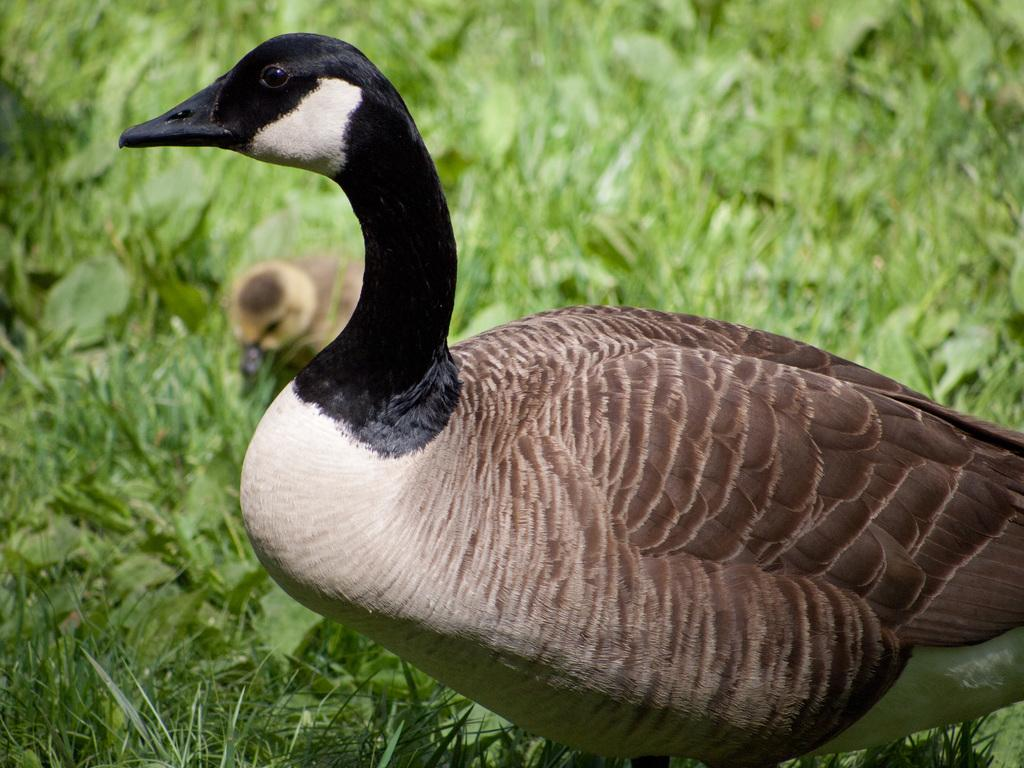What type of animal can be seen in the image? There is a duck in the image. Are there any other animals in the image? Yes, there is a duckling in the image. Where are the duck and duckling located? Both the duck and duckling are on the grass. What type of transportation does the grandmother use to visit the duck and duckling in the image? There is no mention of a grandmother or any form of transportation in the image. 